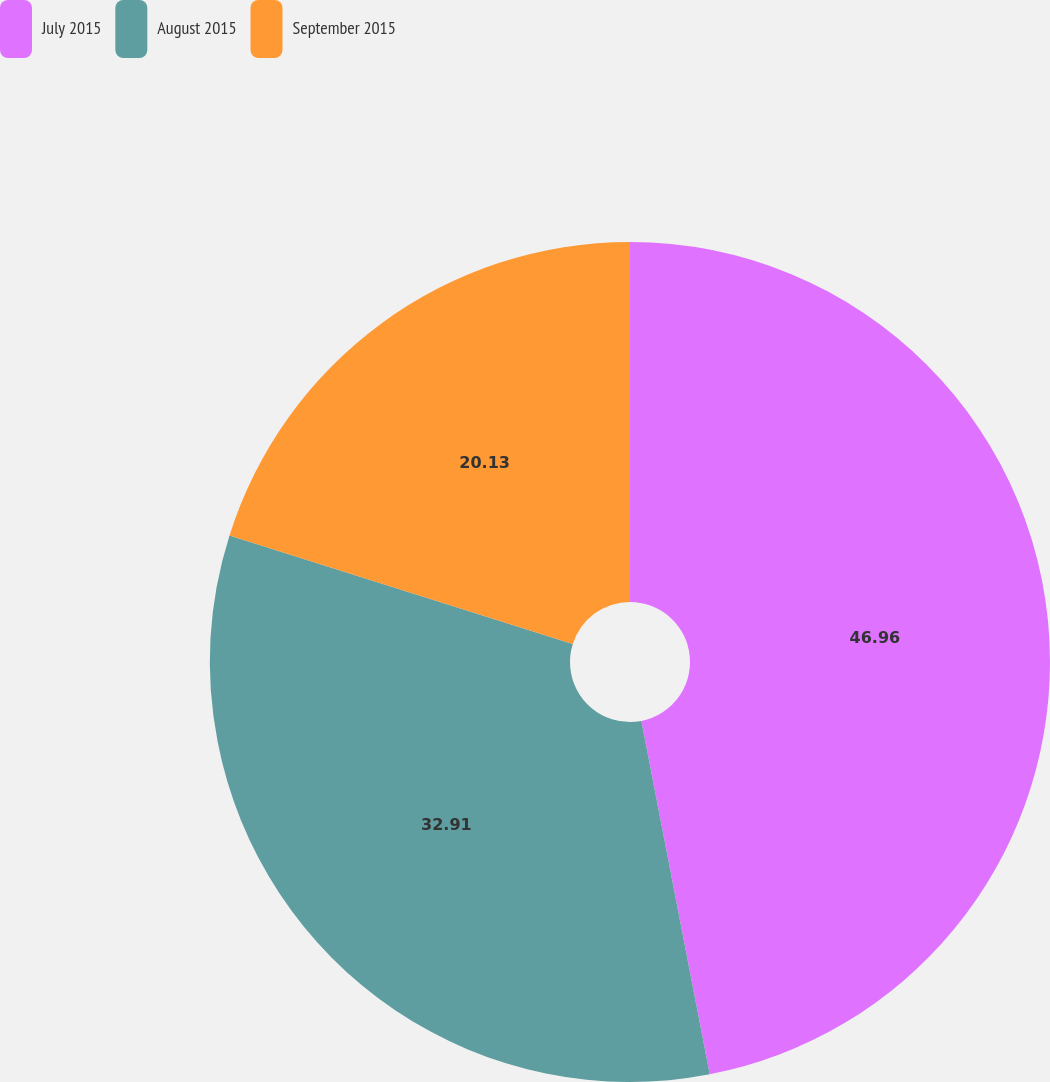Convert chart. <chart><loc_0><loc_0><loc_500><loc_500><pie_chart><fcel>July 2015<fcel>August 2015<fcel>September 2015<nl><fcel>46.96%<fcel>32.91%<fcel>20.13%<nl></chart> 